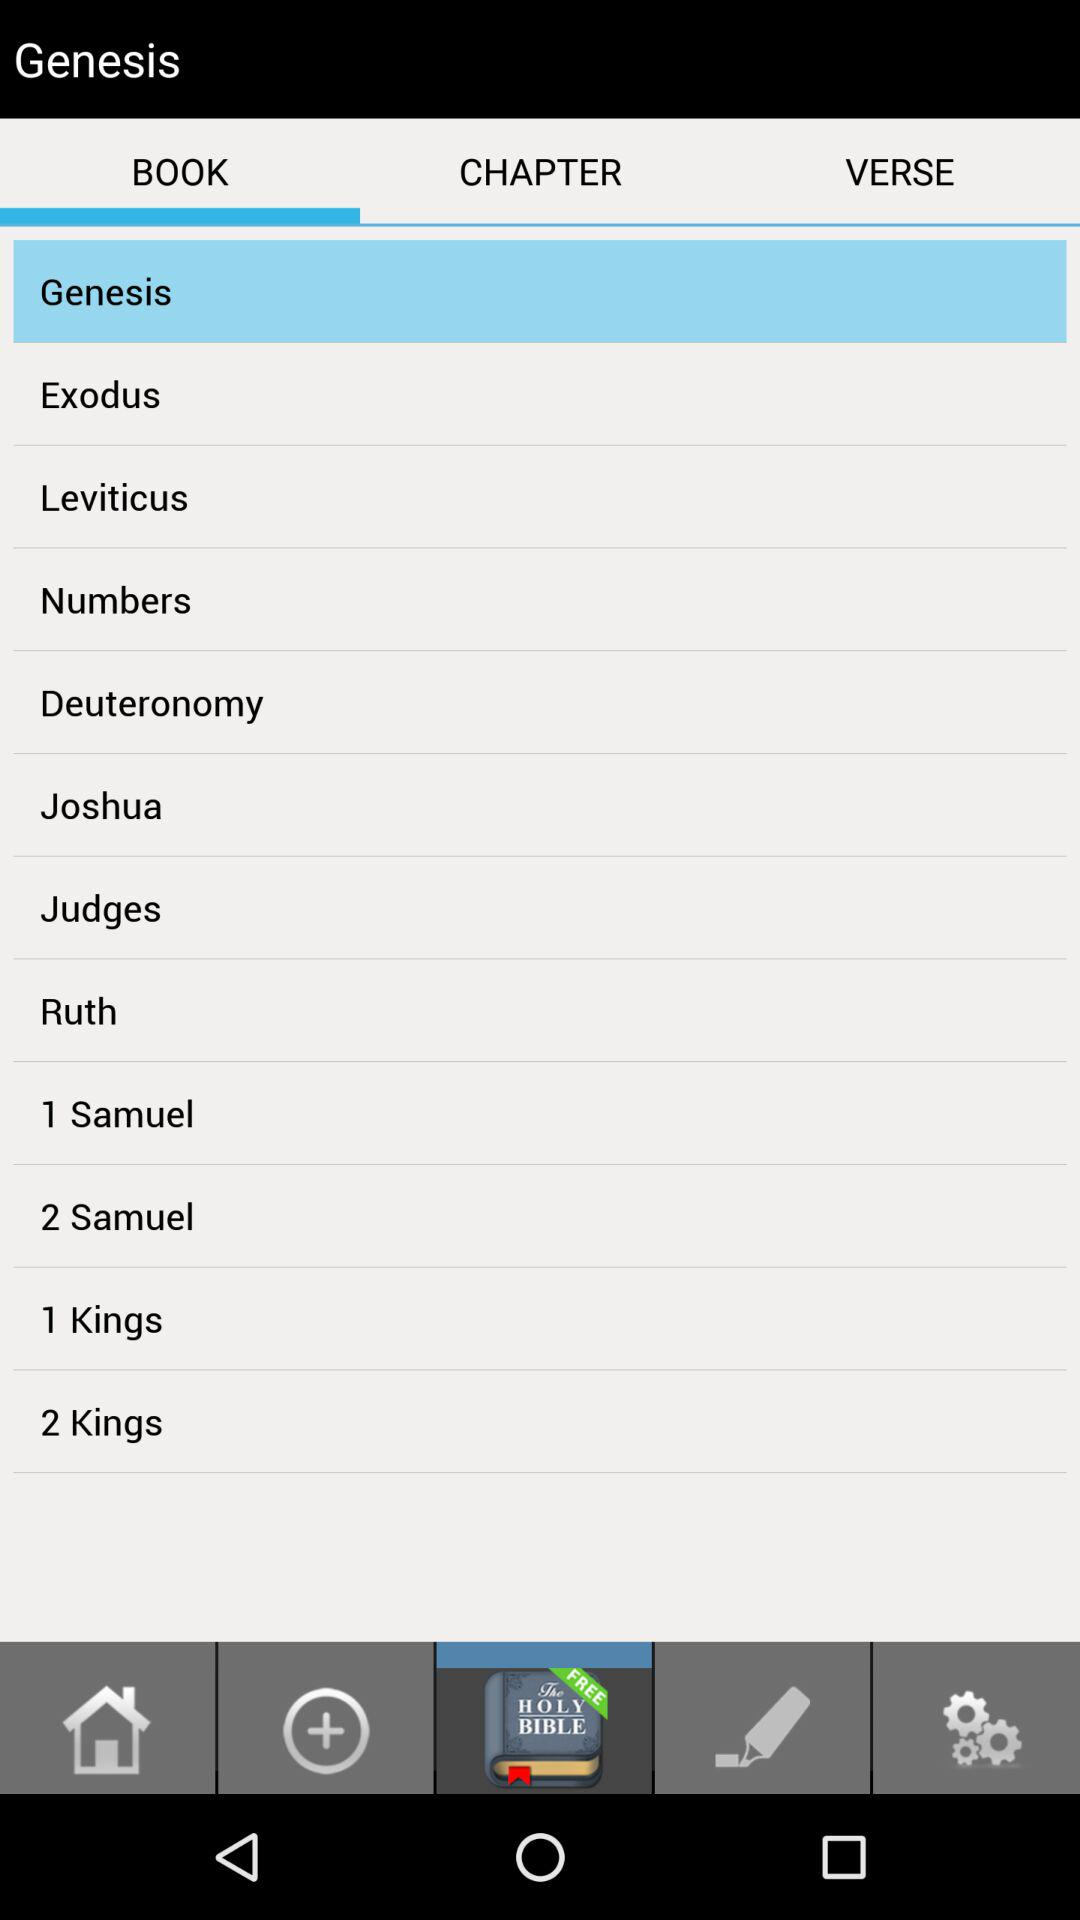Which option has been selected? The selected option is "Genesis". 